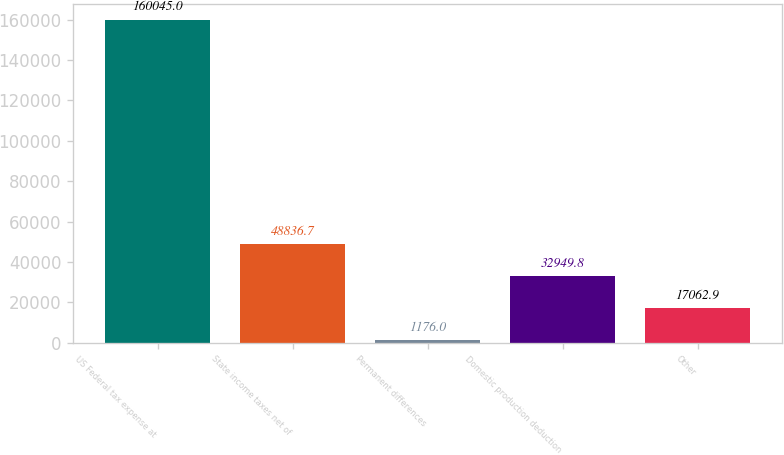Convert chart to OTSL. <chart><loc_0><loc_0><loc_500><loc_500><bar_chart><fcel>US Federal tax expense at<fcel>State income taxes net of<fcel>Permanent differences<fcel>Domestic production deduction<fcel>Other<nl><fcel>160045<fcel>48836.7<fcel>1176<fcel>32949.8<fcel>17062.9<nl></chart> 